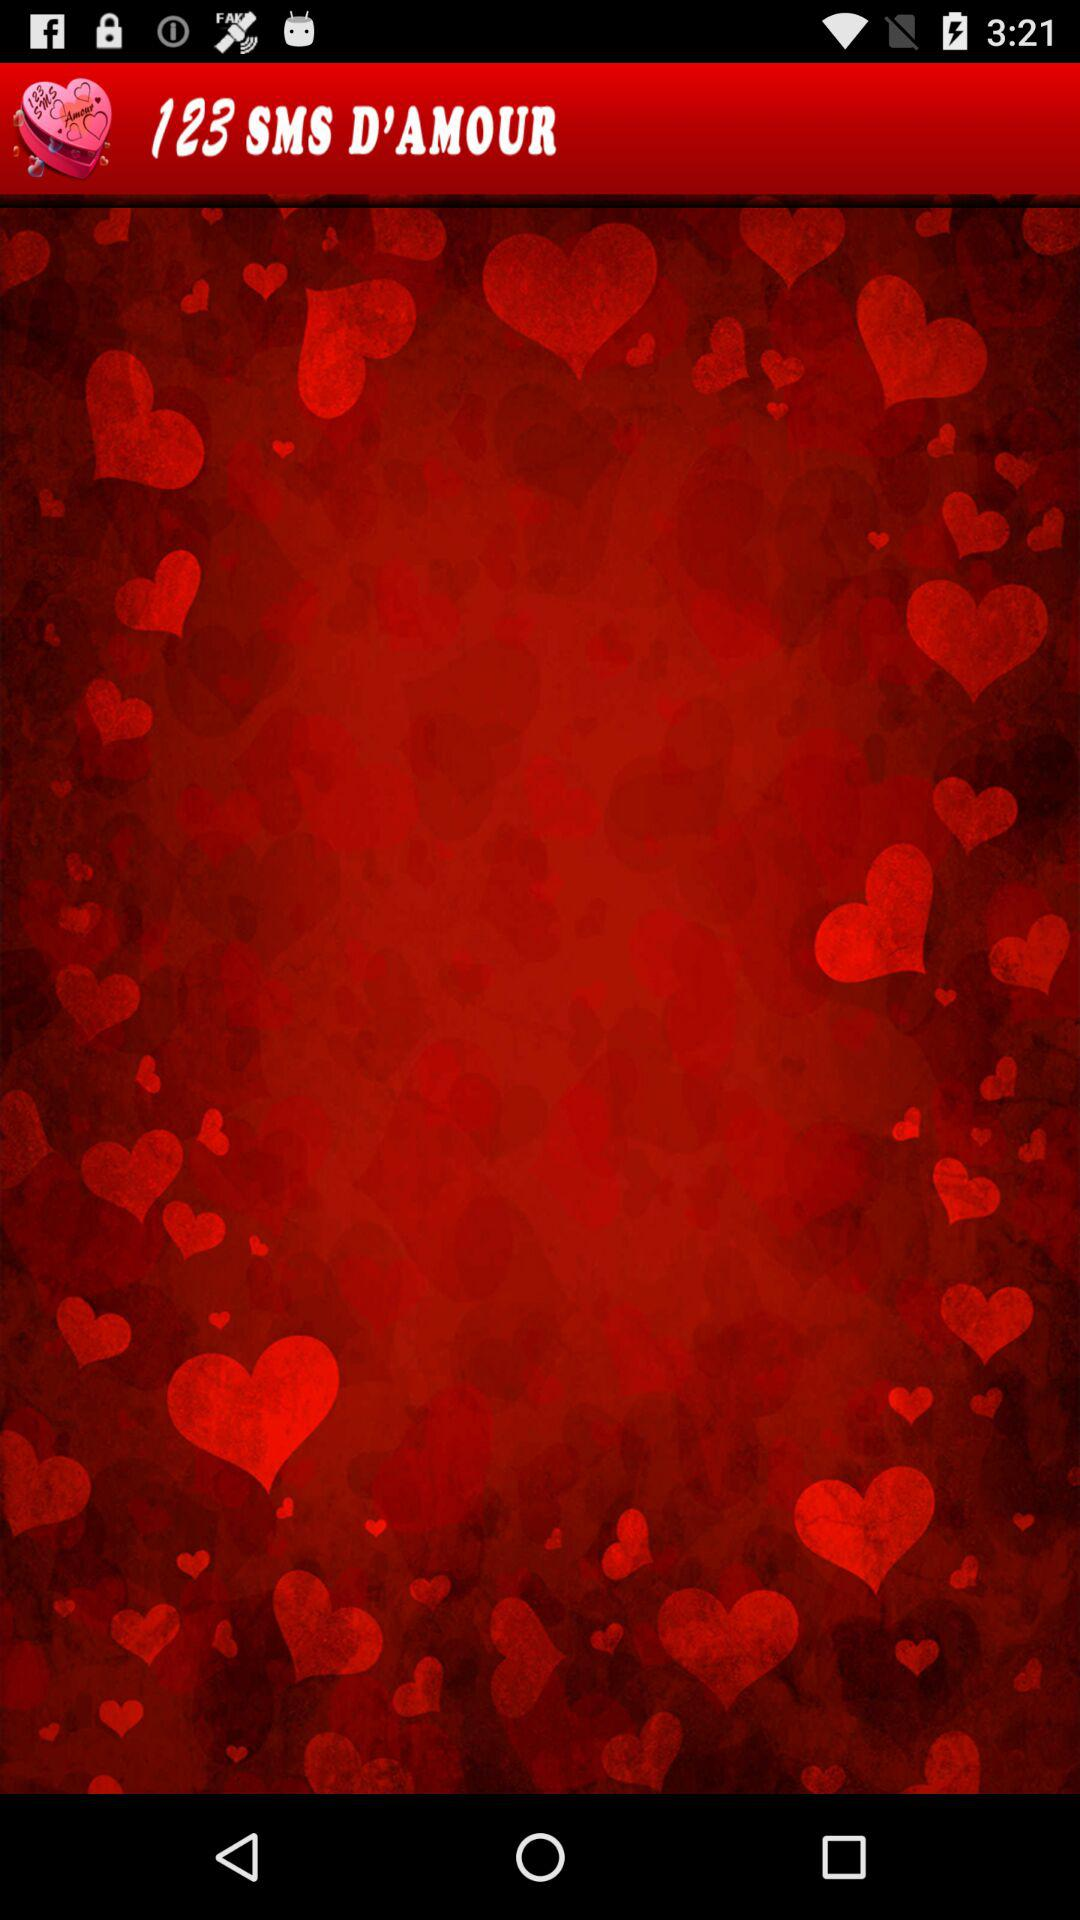What is the application name? The application name is "123 SMS D'AMOUR". 